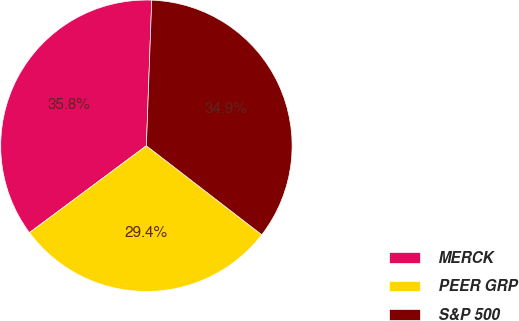Convert chart. <chart><loc_0><loc_0><loc_500><loc_500><pie_chart><fcel>MERCK<fcel>PEER GRP<fcel>S&P 500<nl><fcel>35.75%<fcel>29.37%<fcel>34.87%<nl></chart> 